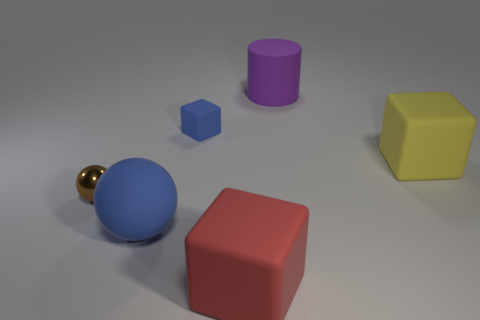Do the small matte object and the large red thing right of the metal ball have the same shape?
Give a very brief answer. Yes. What number of blocks are tiny gray things or rubber things?
Your response must be concise. 3. There is a object that is in front of the blue matte ball; what shape is it?
Offer a very short reply. Cube. How many small blocks have the same material as the large sphere?
Your answer should be very brief. 1. Are there fewer small brown shiny balls in front of the metallic thing than yellow rubber cubes?
Your response must be concise. Yes. What size is the blue rubber thing that is in front of the matte object to the right of the large purple thing?
Your answer should be compact. Large. Is the color of the large rubber cylinder the same as the matte cube that is on the right side of the large purple cylinder?
Your response must be concise. No. There is a ball that is the same size as the red matte cube; what is its material?
Your answer should be compact. Rubber. Are there fewer big yellow rubber cubes that are in front of the big red block than small cubes that are right of the tiny rubber object?
Give a very brief answer. No. There is a tiny object behind the big matte block that is behind the big red thing; what shape is it?
Offer a terse response. Cube. 